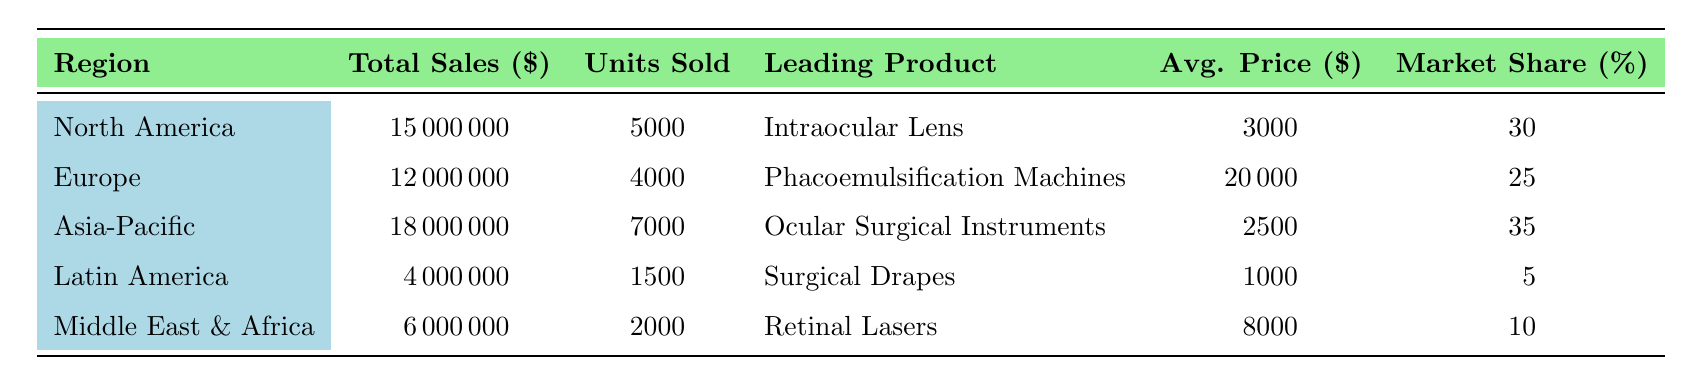What is the total sales for the Asia-Pacific region? The table shows that the total sales for the Asia-Pacific region are listed directly as $18,000,000.
Answer: $18,000,000 Which region has the highest market share? By comparing the market share percentages across all regions, Asia-Pacific has the highest market share at 35%.
Answer: Asia-Pacific What is the average price of the Phacoemulsification Machines? The average price for Phacoemulsification Machines in Europe is listed in the table as $20,000.
Answer: $20,000 How many units were sold in Latin America? The table states that Latin America sold a total of 1,500 units of ocular surgical equipment.
Answer: 1,500 Which product is the leading product in North America? Referring to the table, the leading product in North America is listed as the Intraocular Lens.
Answer: Intraocular Lens What is the total sales for Europe and Latin America combined? To find the total, we add the sales for Europe ($12,000,000) and Latin America ($4,000,000), resulting in $12,000,000 + $4,000,000 = $16,000,000.
Answer: $16,000,000 Is the total sales in the Middle East & Africa greater than that in Latin America? The total sales for the Middle East & Africa ($6,000,000) is greater than the total sales for Latin America ($4,000,000), so this statement is true.
Answer: Yes What is the lowest average price of the products listed? The lowest average price can be found by examining the average prices in the table. The lowest average price is $1,000 for Surgical Drapes in Latin America.
Answer: $1,000 Calculate the total units sold across all regions. To find the total units sold, we add the units sold in each region: 5,000 (North America) + 4,000 (Europe) + 7,000 (Asia-Pacific) + 1,500 (Latin America) + 2,000 (Middle East & Africa) = 19,500.
Answer: 19,500 Which region has the lowest total sales and what is that amount? The table indicates that Latin America has the lowest total sales at $4,000,000.
Answer: $4,000,000 What is the difference in total sales between North America and Asia-Pacific? The total sales for North America is $15,000,000 and for Asia-Pacific it is $18,000,000. The difference is $18,000,000 - $15,000,000 = $3,000,000.
Answer: $3,000,000 